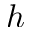Convert formula to latex. <formula><loc_0><loc_0><loc_500><loc_500>h</formula> 